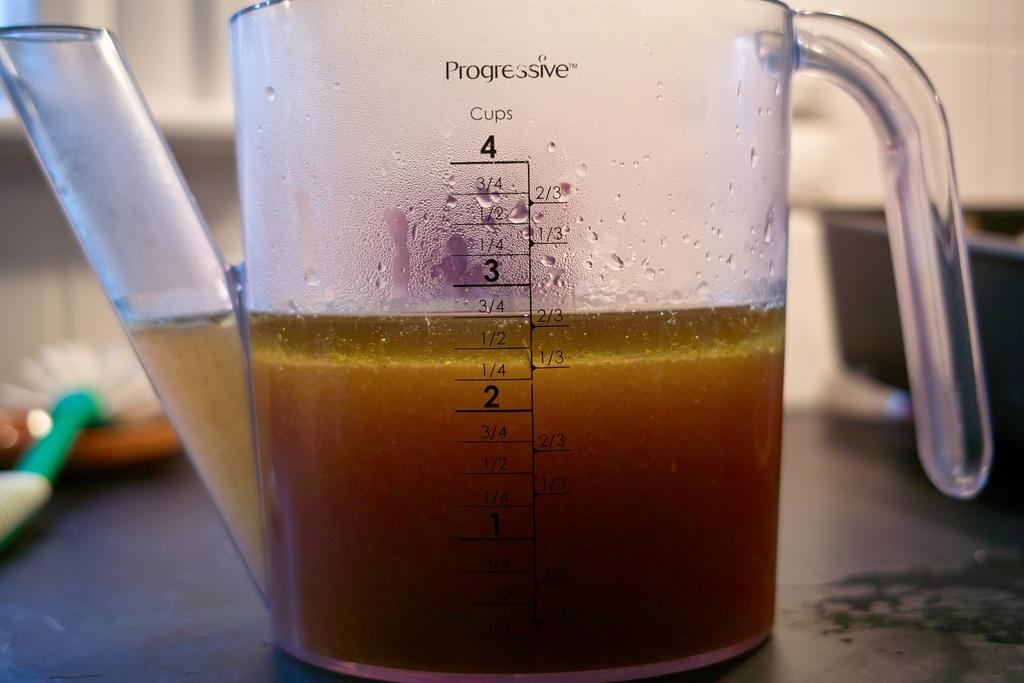How full is this cup?
Your response must be concise. 2 3/4 cups. How much can the cup measure at max?
Your answer should be compact. 4 cups. 